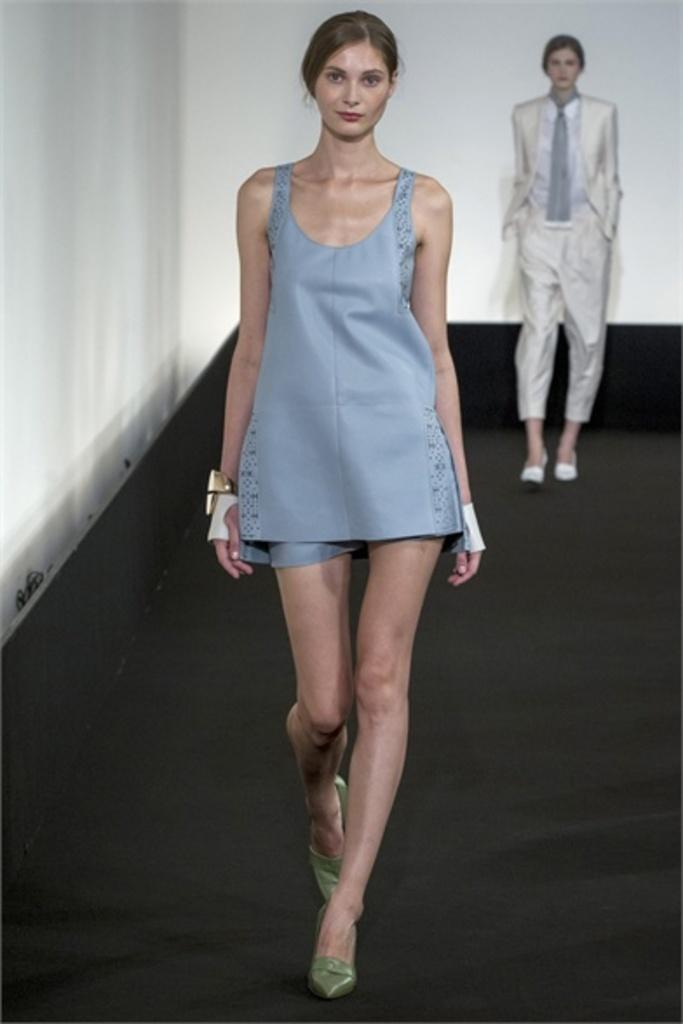How many people are in the image? There are two persons in the image. What are the persons doing in the image? The persons are walking on a pathway. What can be seen in the background of the image? The background of the image is white. What type of canvas is visible in the image? There is no canvas present in the image. How high are the persons jumping in the image? The persons are not jumping in the image; they are walking. 